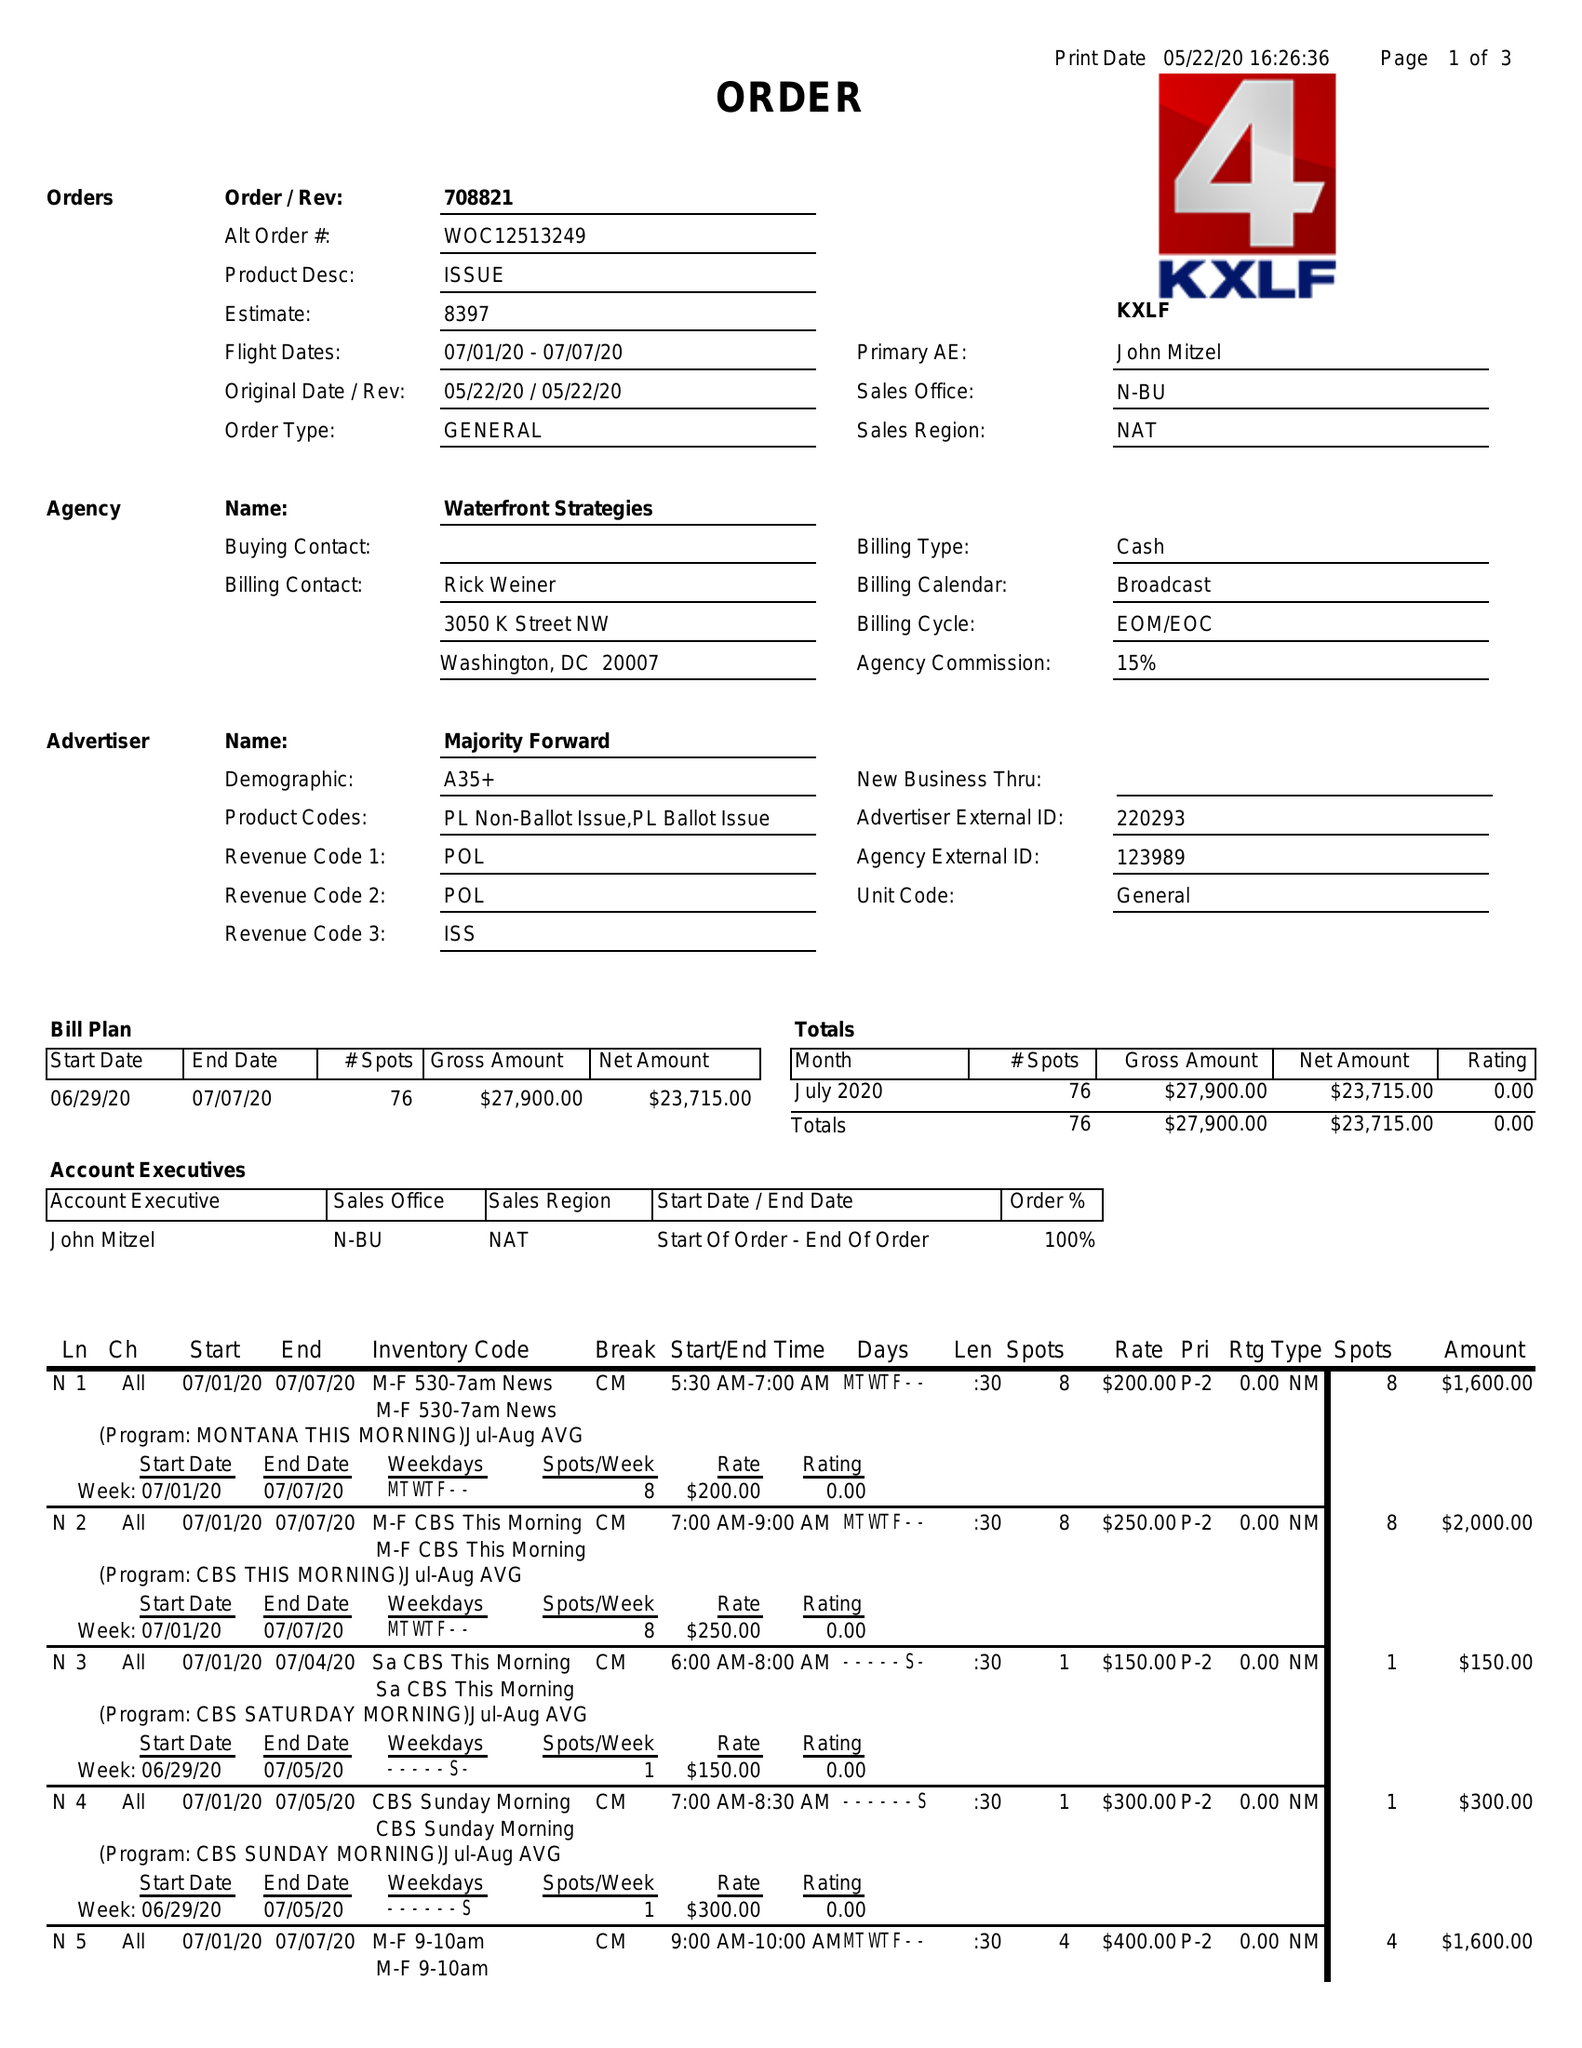What is the value for the contract_num?
Answer the question using a single word or phrase. 708821 